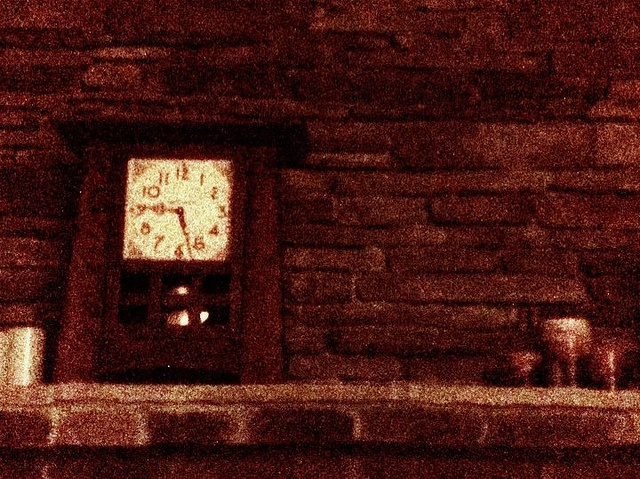Describe the objects in this image and their specific colors. I can see clock in brown, khaki, and tan tones, cup in brown, tan, and salmon tones, cup in brown, maroon, and black tones, and wine glass in brown, maroon, and black tones in this image. 